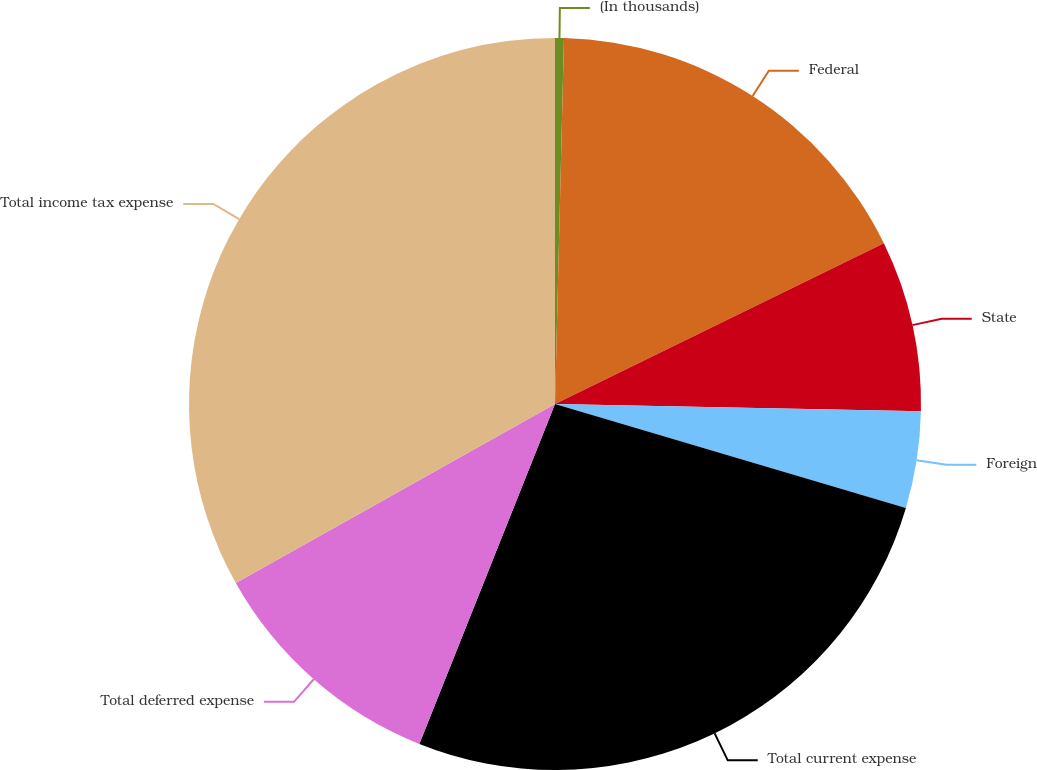Convert chart to OTSL. <chart><loc_0><loc_0><loc_500><loc_500><pie_chart><fcel>(In thousands)<fcel>Federal<fcel>State<fcel>Foreign<fcel>Total current expense<fcel>Total deferred expense<fcel>Total income tax expense<nl><fcel>0.39%<fcel>17.38%<fcel>7.55%<fcel>4.27%<fcel>26.46%<fcel>10.82%<fcel>33.14%<nl></chart> 